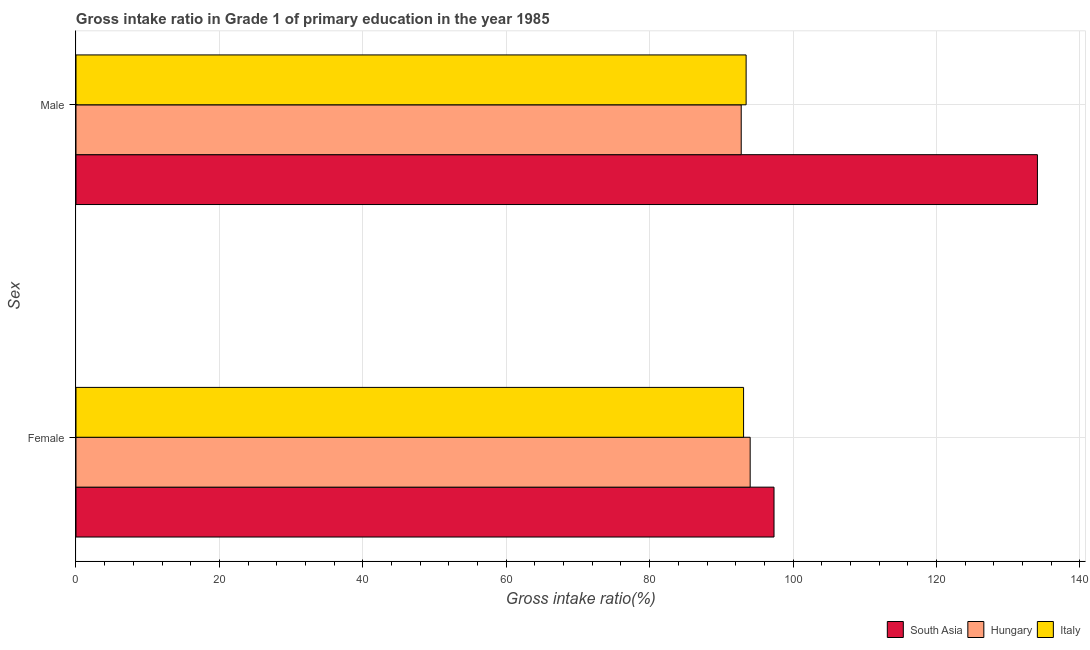How many different coloured bars are there?
Give a very brief answer. 3. How many groups of bars are there?
Provide a short and direct response. 2. How many bars are there on the 1st tick from the bottom?
Your answer should be very brief. 3. What is the gross intake ratio(male) in Hungary?
Provide a short and direct response. 92.77. Across all countries, what is the maximum gross intake ratio(female)?
Make the answer very short. 97.34. Across all countries, what is the minimum gross intake ratio(male)?
Offer a terse response. 92.77. In which country was the gross intake ratio(male) minimum?
Offer a very short reply. Hungary. What is the total gross intake ratio(female) in the graph?
Offer a very short reply. 284.45. What is the difference between the gross intake ratio(female) in Italy and that in South Asia?
Provide a short and direct response. -4.25. What is the difference between the gross intake ratio(female) in Hungary and the gross intake ratio(male) in South Asia?
Provide a short and direct response. -40.06. What is the average gross intake ratio(female) per country?
Offer a terse response. 94.82. What is the difference between the gross intake ratio(male) and gross intake ratio(female) in Italy?
Provide a succinct answer. 0.36. In how many countries, is the gross intake ratio(female) greater than 76 %?
Your answer should be very brief. 3. What is the ratio of the gross intake ratio(male) in Hungary to that in South Asia?
Provide a succinct answer. 0.69. Is the gross intake ratio(female) in Hungary less than that in South Asia?
Offer a terse response. Yes. In how many countries, is the gross intake ratio(male) greater than the average gross intake ratio(male) taken over all countries?
Offer a terse response. 1. What does the 3rd bar from the top in Male represents?
Your answer should be compact. South Asia. Are all the bars in the graph horizontal?
Offer a very short reply. Yes. How many countries are there in the graph?
Give a very brief answer. 3. Are the values on the major ticks of X-axis written in scientific E-notation?
Offer a very short reply. No. Does the graph contain grids?
Give a very brief answer. Yes. Where does the legend appear in the graph?
Provide a short and direct response. Bottom right. How many legend labels are there?
Your answer should be very brief. 3. How are the legend labels stacked?
Make the answer very short. Horizontal. What is the title of the graph?
Keep it short and to the point. Gross intake ratio in Grade 1 of primary education in the year 1985. What is the label or title of the X-axis?
Provide a short and direct response. Gross intake ratio(%). What is the label or title of the Y-axis?
Provide a succinct answer. Sex. What is the Gross intake ratio(%) in South Asia in Female?
Provide a short and direct response. 97.34. What is the Gross intake ratio(%) of Hungary in Female?
Your answer should be very brief. 94.02. What is the Gross intake ratio(%) in Italy in Female?
Keep it short and to the point. 93.1. What is the Gross intake ratio(%) of South Asia in Male?
Give a very brief answer. 134.07. What is the Gross intake ratio(%) of Hungary in Male?
Keep it short and to the point. 92.77. What is the Gross intake ratio(%) of Italy in Male?
Offer a very short reply. 93.45. Across all Sex, what is the maximum Gross intake ratio(%) in South Asia?
Make the answer very short. 134.07. Across all Sex, what is the maximum Gross intake ratio(%) in Hungary?
Your answer should be compact. 94.02. Across all Sex, what is the maximum Gross intake ratio(%) in Italy?
Ensure brevity in your answer.  93.45. Across all Sex, what is the minimum Gross intake ratio(%) of South Asia?
Ensure brevity in your answer.  97.34. Across all Sex, what is the minimum Gross intake ratio(%) in Hungary?
Provide a short and direct response. 92.77. Across all Sex, what is the minimum Gross intake ratio(%) in Italy?
Ensure brevity in your answer.  93.1. What is the total Gross intake ratio(%) of South Asia in the graph?
Offer a very short reply. 231.42. What is the total Gross intake ratio(%) in Hungary in the graph?
Ensure brevity in your answer.  186.78. What is the total Gross intake ratio(%) of Italy in the graph?
Your answer should be compact. 186.55. What is the difference between the Gross intake ratio(%) in South Asia in Female and that in Male?
Provide a succinct answer. -36.73. What is the difference between the Gross intake ratio(%) in Hungary in Female and that in Male?
Make the answer very short. 1.25. What is the difference between the Gross intake ratio(%) in Italy in Female and that in Male?
Ensure brevity in your answer.  -0.36. What is the difference between the Gross intake ratio(%) in South Asia in Female and the Gross intake ratio(%) in Hungary in Male?
Offer a very short reply. 4.57. What is the difference between the Gross intake ratio(%) in South Asia in Female and the Gross intake ratio(%) in Italy in Male?
Your answer should be very brief. 3.89. What is the difference between the Gross intake ratio(%) of Hungary in Female and the Gross intake ratio(%) of Italy in Male?
Your answer should be compact. 0.56. What is the average Gross intake ratio(%) of South Asia per Sex?
Offer a terse response. 115.71. What is the average Gross intake ratio(%) in Hungary per Sex?
Provide a succinct answer. 93.39. What is the average Gross intake ratio(%) of Italy per Sex?
Ensure brevity in your answer.  93.27. What is the difference between the Gross intake ratio(%) in South Asia and Gross intake ratio(%) in Hungary in Female?
Your answer should be very brief. 3.33. What is the difference between the Gross intake ratio(%) in South Asia and Gross intake ratio(%) in Italy in Female?
Give a very brief answer. 4.25. What is the difference between the Gross intake ratio(%) of Hungary and Gross intake ratio(%) of Italy in Female?
Keep it short and to the point. 0.92. What is the difference between the Gross intake ratio(%) in South Asia and Gross intake ratio(%) in Hungary in Male?
Ensure brevity in your answer.  41.31. What is the difference between the Gross intake ratio(%) in South Asia and Gross intake ratio(%) in Italy in Male?
Make the answer very short. 40.62. What is the difference between the Gross intake ratio(%) of Hungary and Gross intake ratio(%) of Italy in Male?
Ensure brevity in your answer.  -0.68. What is the ratio of the Gross intake ratio(%) in South Asia in Female to that in Male?
Offer a very short reply. 0.73. What is the ratio of the Gross intake ratio(%) in Hungary in Female to that in Male?
Your answer should be very brief. 1.01. What is the ratio of the Gross intake ratio(%) in Italy in Female to that in Male?
Make the answer very short. 1. What is the difference between the highest and the second highest Gross intake ratio(%) in South Asia?
Keep it short and to the point. 36.73. What is the difference between the highest and the second highest Gross intake ratio(%) of Hungary?
Provide a succinct answer. 1.25. What is the difference between the highest and the second highest Gross intake ratio(%) in Italy?
Offer a terse response. 0.36. What is the difference between the highest and the lowest Gross intake ratio(%) of South Asia?
Offer a terse response. 36.73. What is the difference between the highest and the lowest Gross intake ratio(%) in Hungary?
Make the answer very short. 1.25. What is the difference between the highest and the lowest Gross intake ratio(%) of Italy?
Your answer should be compact. 0.36. 